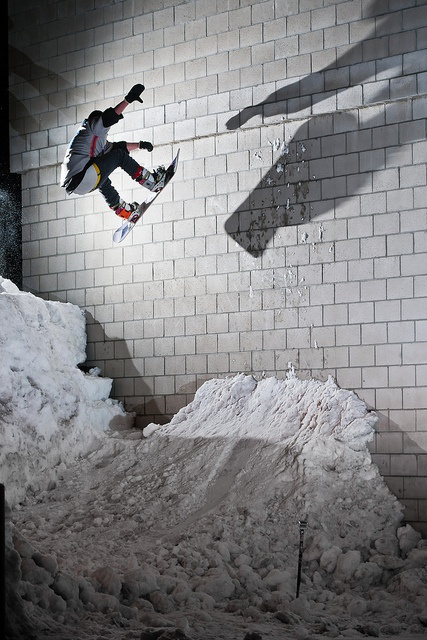Describe the objects in this image and their specific colors. I can see people in black, gray, lightgray, and darkgray tones and snowboard in black, lightgray, gray, and darkgray tones in this image. 